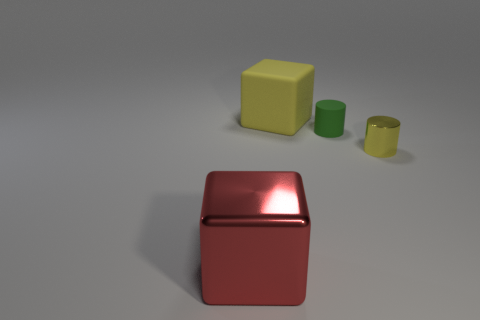Is the number of red shiny blocks behind the big shiny cube less than the number of shiny cubes?
Your answer should be compact. Yes. What shape is the other thing that is the same material as the large red thing?
Your answer should be very brief. Cylinder. How many metallic objects are yellow cylinders or small green things?
Ensure brevity in your answer.  1. Are there an equal number of small green matte cylinders that are to the right of the green object and large blue balls?
Keep it short and to the point. Yes. Is the color of the big block behind the red metallic cube the same as the small shiny thing?
Your answer should be very brief. Yes. There is a object that is both in front of the green thing and behind the red object; what is its material?
Make the answer very short. Metal. Is there a small rubber thing on the right side of the large thing that is on the right side of the big red block?
Offer a terse response. Yes. Are the red block and the tiny green cylinder made of the same material?
Provide a short and direct response. No. There is a thing that is behind the small metallic cylinder and in front of the yellow cube; what shape is it?
Keep it short and to the point. Cylinder. What size is the cube that is in front of the big block behind the yellow metallic cylinder?
Your answer should be compact. Large. 